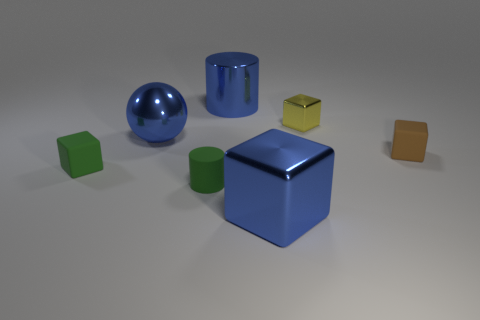Add 3 big blue things. How many objects exist? 10 Subtract all big shiny blocks. How many blocks are left? 3 Subtract 2 cubes. How many cubes are left? 2 Subtract all brown blocks. How many blocks are left? 3 Subtract all spheres. How many objects are left? 6 Subtract all brown blocks. Subtract all gray cylinders. How many blocks are left? 3 Subtract all blue cylinders. How many green blocks are left? 1 Subtract all tiny brown rubber objects. Subtract all blue objects. How many objects are left? 3 Add 7 green matte cylinders. How many green matte cylinders are left? 8 Add 4 big blue metal cubes. How many big blue metal cubes exist? 5 